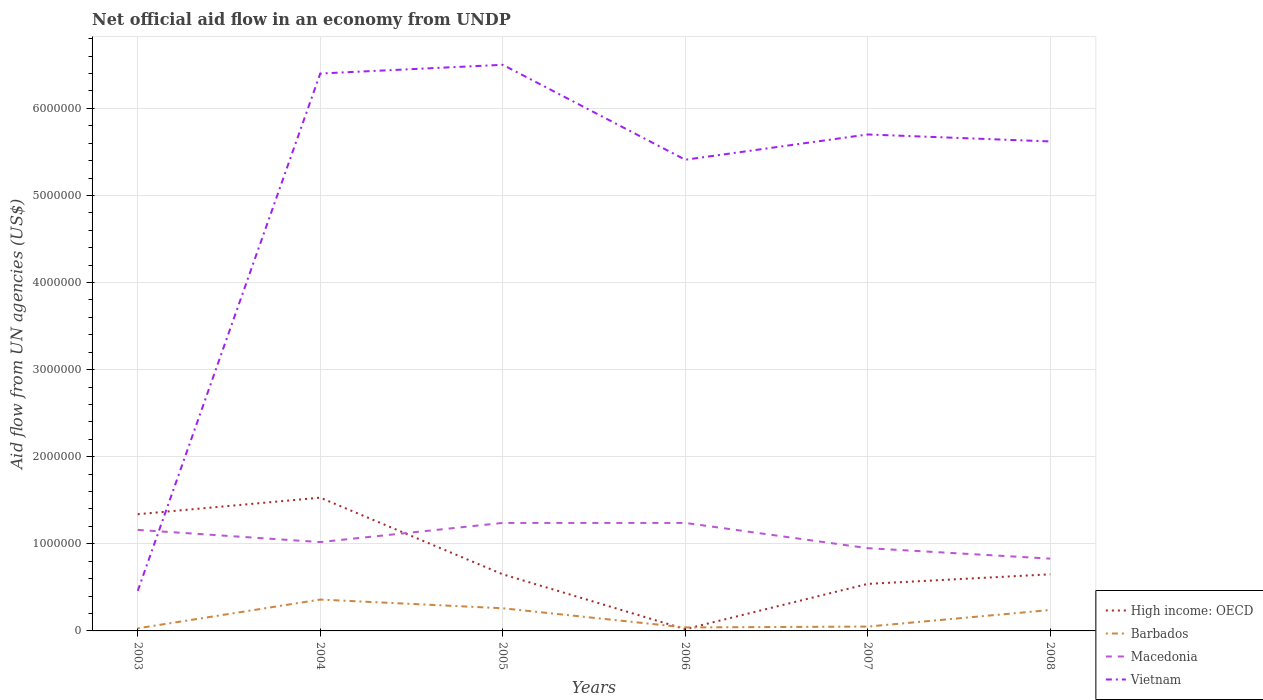How many different coloured lines are there?
Your answer should be very brief. 4. Is the number of lines equal to the number of legend labels?
Your answer should be compact. Yes. Across all years, what is the maximum net official aid flow in High income: OECD?
Offer a very short reply. 2.00e+04. What is the difference between the highest and the second highest net official aid flow in High income: OECD?
Provide a short and direct response. 1.51e+06. How many lines are there?
Offer a terse response. 4. How many years are there in the graph?
Offer a very short reply. 6. What is the difference between two consecutive major ticks on the Y-axis?
Ensure brevity in your answer.  1.00e+06. How many legend labels are there?
Offer a terse response. 4. What is the title of the graph?
Keep it short and to the point. Net official aid flow in an economy from UNDP. What is the label or title of the X-axis?
Your response must be concise. Years. What is the label or title of the Y-axis?
Offer a very short reply. Aid flow from UN agencies (US$). What is the Aid flow from UN agencies (US$) of High income: OECD in 2003?
Offer a terse response. 1.34e+06. What is the Aid flow from UN agencies (US$) in Barbados in 2003?
Your answer should be compact. 3.00e+04. What is the Aid flow from UN agencies (US$) in Macedonia in 2003?
Offer a very short reply. 1.16e+06. What is the Aid flow from UN agencies (US$) in High income: OECD in 2004?
Your response must be concise. 1.53e+06. What is the Aid flow from UN agencies (US$) in Barbados in 2004?
Provide a succinct answer. 3.60e+05. What is the Aid flow from UN agencies (US$) of Macedonia in 2004?
Offer a very short reply. 1.02e+06. What is the Aid flow from UN agencies (US$) of Vietnam in 2004?
Keep it short and to the point. 6.40e+06. What is the Aid flow from UN agencies (US$) of High income: OECD in 2005?
Your response must be concise. 6.50e+05. What is the Aid flow from UN agencies (US$) in Barbados in 2005?
Keep it short and to the point. 2.60e+05. What is the Aid flow from UN agencies (US$) in Macedonia in 2005?
Your response must be concise. 1.24e+06. What is the Aid flow from UN agencies (US$) in Vietnam in 2005?
Keep it short and to the point. 6.50e+06. What is the Aid flow from UN agencies (US$) in Macedonia in 2006?
Give a very brief answer. 1.24e+06. What is the Aid flow from UN agencies (US$) in Vietnam in 2006?
Your answer should be very brief. 5.41e+06. What is the Aid flow from UN agencies (US$) of High income: OECD in 2007?
Your answer should be very brief. 5.40e+05. What is the Aid flow from UN agencies (US$) in Barbados in 2007?
Ensure brevity in your answer.  5.00e+04. What is the Aid flow from UN agencies (US$) of Macedonia in 2007?
Give a very brief answer. 9.50e+05. What is the Aid flow from UN agencies (US$) of Vietnam in 2007?
Ensure brevity in your answer.  5.70e+06. What is the Aid flow from UN agencies (US$) of High income: OECD in 2008?
Give a very brief answer. 6.50e+05. What is the Aid flow from UN agencies (US$) of Macedonia in 2008?
Provide a short and direct response. 8.30e+05. What is the Aid flow from UN agencies (US$) in Vietnam in 2008?
Make the answer very short. 5.62e+06. Across all years, what is the maximum Aid flow from UN agencies (US$) of High income: OECD?
Keep it short and to the point. 1.53e+06. Across all years, what is the maximum Aid flow from UN agencies (US$) of Barbados?
Provide a succinct answer. 3.60e+05. Across all years, what is the maximum Aid flow from UN agencies (US$) of Macedonia?
Offer a terse response. 1.24e+06. Across all years, what is the maximum Aid flow from UN agencies (US$) in Vietnam?
Keep it short and to the point. 6.50e+06. Across all years, what is the minimum Aid flow from UN agencies (US$) of High income: OECD?
Provide a short and direct response. 2.00e+04. Across all years, what is the minimum Aid flow from UN agencies (US$) in Macedonia?
Make the answer very short. 8.30e+05. Across all years, what is the minimum Aid flow from UN agencies (US$) in Vietnam?
Provide a short and direct response. 4.60e+05. What is the total Aid flow from UN agencies (US$) of High income: OECD in the graph?
Your answer should be compact. 4.73e+06. What is the total Aid flow from UN agencies (US$) of Barbados in the graph?
Offer a terse response. 9.80e+05. What is the total Aid flow from UN agencies (US$) of Macedonia in the graph?
Provide a succinct answer. 6.44e+06. What is the total Aid flow from UN agencies (US$) of Vietnam in the graph?
Your response must be concise. 3.01e+07. What is the difference between the Aid flow from UN agencies (US$) in Barbados in 2003 and that in 2004?
Ensure brevity in your answer.  -3.30e+05. What is the difference between the Aid flow from UN agencies (US$) of Macedonia in 2003 and that in 2004?
Your answer should be very brief. 1.40e+05. What is the difference between the Aid flow from UN agencies (US$) in Vietnam in 2003 and that in 2004?
Offer a very short reply. -5.94e+06. What is the difference between the Aid flow from UN agencies (US$) of High income: OECD in 2003 and that in 2005?
Offer a terse response. 6.90e+05. What is the difference between the Aid flow from UN agencies (US$) in Vietnam in 2003 and that in 2005?
Ensure brevity in your answer.  -6.04e+06. What is the difference between the Aid flow from UN agencies (US$) of High income: OECD in 2003 and that in 2006?
Your answer should be very brief. 1.32e+06. What is the difference between the Aid flow from UN agencies (US$) of Barbados in 2003 and that in 2006?
Offer a terse response. -10000. What is the difference between the Aid flow from UN agencies (US$) of Macedonia in 2003 and that in 2006?
Give a very brief answer. -8.00e+04. What is the difference between the Aid flow from UN agencies (US$) of Vietnam in 2003 and that in 2006?
Provide a short and direct response. -4.95e+06. What is the difference between the Aid flow from UN agencies (US$) of Vietnam in 2003 and that in 2007?
Provide a short and direct response. -5.24e+06. What is the difference between the Aid flow from UN agencies (US$) in High income: OECD in 2003 and that in 2008?
Your answer should be very brief. 6.90e+05. What is the difference between the Aid flow from UN agencies (US$) of Barbados in 2003 and that in 2008?
Your response must be concise. -2.10e+05. What is the difference between the Aid flow from UN agencies (US$) in Macedonia in 2003 and that in 2008?
Keep it short and to the point. 3.30e+05. What is the difference between the Aid flow from UN agencies (US$) in Vietnam in 2003 and that in 2008?
Provide a short and direct response. -5.16e+06. What is the difference between the Aid flow from UN agencies (US$) of High income: OECD in 2004 and that in 2005?
Offer a very short reply. 8.80e+05. What is the difference between the Aid flow from UN agencies (US$) in Barbados in 2004 and that in 2005?
Ensure brevity in your answer.  1.00e+05. What is the difference between the Aid flow from UN agencies (US$) of Vietnam in 2004 and that in 2005?
Make the answer very short. -1.00e+05. What is the difference between the Aid flow from UN agencies (US$) in High income: OECD in 2004 and that in 2006?
Your answer should be compact. 1.51e+06. What is the difference between the Aid flow from UN agencies (US$) of Vietnam in 2004 and that in 2006?
Your answer should be very brief. 9.90e+05. What is the difference between the Aid flow from UN agencies (US$) in High income: OECD in 2004 and that in 2007?
Offer a very short reply. 9.90e+05. What is the difference between the Aid flow from UN agencies (US$) of Barbados in 2004 and that in 2007?
Ensure brevity in your answer.  3.10e+05. What is the difference between the Aid flow from UN agencies (US$) of Vietnam in 2004 and that in 2007?
Provide a succinct answer. 7.00e+05. What is the difference between the Aid flow from UN agencies (US$) in High income: OECD in 2004 and that in 2008?
Provide a short and direct response. 8.80e+05. What is the difference between the Aid flow from UN agencies (US$) of Vietnam in 2004 and that in 2008?
Your answer should be compact. 7.80e+05. What is the difference between the Aid flow from UN agencies (US$) in High income: OECD in 2005 and that in 2006?
Your response must be concise. 6.30e+05. What is the difference between the Aid flow from UN agencies (US$) of Barbados in 2005 and that in 2006?
Make the answer very short. 2.20e+05. What is the difference between the Aid flow from UN agencies (US$) in Macedonia in 2005 and that in 2006?
Give a very brief answer. 0. What is the difference between the Aid flow from UN agencies (US$) in Vietnam in 2005 and that in 2006?
Provide a succinct answer. 1.09e+06. What is the difference between the Aid flow from UN agencies (US$) in High income: OECD in 2005 and that in 2007?
Give a very brief answer. 1.10e+05. What is the difference between the Aid flow from UN agencies (US$) of Macedonia in 2005 and that in 2007?
Offer a very short reply. 2.90e+05. What is the difference between the Aid flow from UN agencies (US$) of Vietnam in 2005 and that in 2007?
Provide a short and direct response. 8.00e+05. What is the difference between the Aid flow from UN agencies (US$) in Vietnam in 2005 and that in 2008?
Provide a short and direct response. 8.80e+05. What is the difference between the Aid flow from UN agencies (US$) in High income: OECD in 2006 and that in 2007?
Your response must be concise. -5.20e+05. What is the difference between the Aid flow from UN agencies (US$) of Barbados in 2006 and that in 2007?
Provide a short and direct response. -10000. What is the difference between the Aid flow from UN agencies (US$) in Vietnam in 2006 and that in 2007?
Offer a terse response. -2.90e+05. What is the difference between the Aid flow from UN agencies (US$) of High income: OECD in 2006 and that in 2008?
Your answer should be very brief. -6.30e+05. What is the difference between the Aid flow from UN agencies (US$) in Vietnam in 2006 and that in 2008?
Ensure brevity in your answer.  -2.10e+05. What is the difference between the Aid flow from UN agencies (US$) in High income: OECD in 2007 and that in 2008?
Offer a terse response. -1.10e+05. What is the difference between the Aid flow from UN agencies (US$) in Barbados in 2007 and that in 2008?
Make the answer very short. -1.90e+05. What is the difference between the Aid flow from UN agencies (US$) in High income: OECD in 2003 and the Aid flow from UN agencies (US$) in Barbados in 2004?
Give a very brief answer. 9.80e+05. What is the difference between the Aid flow from UN agencies (US$) of High income: OECD in 2003 and the Aid flow from UN agencies (US$) of Vietnam in 2004?
Your answer should be very brief. -5.06e+06. What is the difference between the Aid flow from UN agencies (US$) in Barbados in 2003 and the Aid flow from UN agencies (US$) in Macedonia in 2004?
Offer a terse response. -9.90e+05. What is the difference between the Aid flow from UN agencies (US$) of Barbados in 2003 and the Aid flow from UN agencies (US$) of Vietnam in 2004?
Give a very brief answer. -6.37e+06. What is the difference between the Aid flow from UN agencies (US$) of Macedonia in 2003 and the Aid flow from UN agencies (US$) of Vietnam in 2004?
Provide a short and direct response. -5.24e+06. What is the difference between the Aid flow from UN agencies (US$) of High income: OECD in 2003 and the Aid flow from UN agencies (US$) of Barbados in 2005?
Your response must be concise. 1.08e+06. What is the difference between the Aid flow from UN agencies (US$) in High income: OECD in 2003 and the Aid flow from UN agencies (US$) in Macedonia in 2005?
Offer a terse response. 1.00e+05. What is the difference between the Aid flow from UN agencies (US$) of High income: OECD in 2003 and the Aid flow from UN agencies (US$) of Vietnam in 2005?
Make the answer very short. -5.16e+06. What is the difference between the Aid flow from UN agencies (US$) in Barbados in 2003 and the Aid flow from UN agencies (US$) in Macedonia in 2005?
Your answer should be very brief. -1.21e+06. What is the difference between the Aid flow from UN agencies (US$) of Barbados in 2003 and the Aid flow from UN agencies (US$) of Vietnam in 2005?
Make the answer very short. -6.47e+06. What is the difference between the Aid flow from UN agencies (US$) of Macedonia in 2003 and the Aid flow from UN agencies (US$) of Vietnam in 2005?
Your answer should be compact. -5.34e+06. What is the difference between the Aid flow from UN agencies (US$) of High income: OECD in 2003 and the Aid flow from UN agencies (US$) of Barbados in 2006?
Your answer should be compact. 1.30e+06. What is the difference between the Aid flow from UN agencies (US$) in High income: OECD in 2003 and the Aid flow from UN agencies (US$) in Macedonia in 2006?
Your response must be concise. 1.00e+05. What is the difference between the Aid flow from UN agencies (US$) of High income: OECD in 2003 and the Aid flow from UN agencies (US$) of Vietnam in 2006?
Keep it short and to the point. -4.07e+06. What is the difference between the Aid flow from UN agencies (US$) of Barbados in 2003 and the Aid flow from UN agencies (US$) of Macedonia in 2006?
Keep it short and to the point. -1.21e+06. What is the difference between the Aid flow from UN agencies (US$) in Barbados in 2003 and the Aid flow from UN agencies (US$) in Vietnam in 2006?
Provide a short and direct response. -5.38e+06. What is the difference between the Aid flow from UN agencies (US$) of Macedonia in 2003 and the Aid flow from UN agencies (US$) of Vietnam in 2006?
Give a very brief answer. -4.25e+06. What is the difference between the Aid flow from UN agencies (US$) of High income: OECD in 2003 and the Aid flow from UN agencies (US$) of Barbados in 2007?
Make the answer very short. 1.29e+06. What is the difference between the Aid flow from UN agencies (US$) of High income: OECD in 2003 and the Aid flow from UN agencies (US$) of Vietnam in 2007?
Give a very brief answer. -4.36e+06. What is the difference between the Aid flow from UN agencies (US$) of Barbados in 2003 and the Aid flow from UN agencies (US$) of Macedonia in 2007?
Keep it short and to the point. -9.20e+05. What is the difference between the Aid flow from UN agencies (US$) in Barbados in 2003 and the Aid flow from UN agencies (US$) in Vietnam in 2007?
Provide a short and direct response. -5.67e+06. What is the difference between the Aid flow from UN agencies (US$) of Macedonia in 2003 and the Aid flow from UN agencies (US$) of Vietnam in 2007?
Offer a very short reply. -4.54e+06. What is the difference between the Aid flow from UN agencies (US$) in High income: OECD in 2003 and the Aid flow from UN agencies (US$) in Barbados in 2008?
Your answer should be very brief. 1.10e+06. What is the difference between the Aid flow from UN agencies (US$) in High income: OECD in 2003 and the Aid flow from UN agencies (US$) in Macedonia in 2008?
Make the answer very short. 5.10e+05. What is the difference between the Aid flow from UN agencies (US$) in High income: OECD in 2003 and the Aid flow from UN agencies (US$) in Vietnam in 2008?
Ensure brevity in your answer.  -4.28e+06. What is the difference between the Aid flow from UN agencies (US$) of Barbados in 2003 and the Aid flow from UN agencies (US$) of Macedonia in 2008?
Make the answer very short. -8.00e+05. What is the difference between the Aid flow from UN agencies (US$) of Barbados in 2003 and the Aid flow from UN agencies (US$) of Vietnam in 2008?
Offer a very short reply. -5.59e+06. What is the difference between the Aid flow from UN agencies (US$) in Macedonia in 2003 and the Aid flow from UN agencies (US$) in Vietnam in 2008?
Offer a terse response. -4.46e+06. What is the difference between the Aid flow from UN agencies (US$) of High income: OECD in 2004 and the Aid flow from UN agencies (US$) of Barbados in 2005?
Your response must be concise. 1.27e+06. What is the difference between the Aid flow from UN agencies (US$) of High income: OECD in 2004 and the Aid flow from UN agencies (US$) of Vietnam in 2005?
Make the answer very short. -4.97e+06. What is the difference between the Aid flow from UN agencies (US$) of Barbados in 2004 and the Aid flow from UN agencies (US$) of Macedonia in 2005?
Your answer should be compact. -8.80e+05. What is the difference between the Aid flow from UN agencies (US$) of Barbados in 2004 and the Aid flow from UN agencies (US$) of Vietnam in 2005?
Your response must be concise. -6.14e+06. What is the difference between the Aid flow from UN agencies (US$) in Macedonia in 2004 and the Aid flow from UN agencies (US$) in Vietnam in 2005?
Make the answer very short. -5.48e+06. What is the difference between the Aid flow from UN agencies (US$) in High income: OECD in 2004 and the Aid flow from UN agencies (US$) in Barbados in 2006?
Ensure brevity in your answer.  1.49e+06. What is the difference between the Aid flow from UN agencies (US$) of High income: OECD in 2004 and the Aid flow from UN agencies (US$) of Vietnam in 2006?
Your response must be concise. -3.88e+06. What is the difference between the Aid flow from UN agencies (US$) in Barbados in 2004 and the Aid flow from UN agencies (US$) in Macedonia in 2006?
Give a very brief answer. -8.80e+05. What is the difference between the Aid flow from UN agencies (US$) in Barbados in 2004 and the Aid flow from UN agencies (US$) in Vietnam in 2006?
Offer a terse response. -5.05e+06. What is the difference between the Aid flow from UN agencies (US$) of Macedonia in 2004 and the Aid flow from UN agencies (US$) of Vietnam in 2006?
Provide a succinct answer. -4.39e+06. What is the difference between the Aid flow from UN agencies (US$) in High income: OECD in 2004 and the Aid flow from UN agencies (US$) in Barbados in 2007?
Provide a succinct answer. 1.48e+06. What is the difference between the Aid flow from UN agencies (US$) of High income: OECD in 2004 and the Aid flow from UN agencies (US$) of Macedonia in 2007?
Your response must be concise. 5.80e+05. What is the difference between the Aid flow from UN agencies (US$) in High income: OECD in 2004 and the Aid flow from UN agencies (US$) in Vietnam in 2007?
Provide a succinct answer. -4.17e+06. What is the difference between the Aid flow from UN agencies (US$) in Barbados in 2004 and the Aid flow from UN agencies (US$) in Macedonia in 2007?
Your answer should be compact. -5.90e+05. What is the difference between the Aid flow from UN agencies (US$) in Barbados in 2004 and the Aid flow from UN agencies (US$) in Vietnam in 2007?
Your answer should be compact. -5.34e+06. What is the difference between the Aid flow from UN agencies (US$) of Macedonia in 2004 and the Aid flow from UN agencies (US$) of Vietnam in 2007?
Give a very brief answer. -4.68e+06. What is the difference between the Aid flow from UN agencies (US$) of High income: OECD in 2004 and the Aid flow from UN agencies (US$) of Barbados in 2008?
Offer a terse response. 1.29e+06. What is the difference between the Aid flow from UN agencies (US$) in High income: OECD in 2004 and the Aid flow from UN agencies (US$) in Vietnam in 2008?
Provide a short and direct response. -4.09e+06. What is the difference between the Aid flow from UN agencies (US$) in Barbados in 2004 and the Aid flow from UN agencies (US$) in Macedonia in 2008?
Keep it short and to the point. -4.70e+05. What is the difference between the Aid flow from UN agencies (US$) of Barbados in 2004 and the Aid flow from UN agencies (US$) of Vietnam in 2008?
Ensure brevity in your answer.  -5.26e+06. What is the difference between the Aid flow from UN agencies (US$) in Macedonia in 2004 and the Aid flow from UN agencies (US$) in Vietnam in 2008?
Offer a very short reply. -4.60e+06. What is the difference between the Aid flow from UN agencies (US$) of High income: OECD in 2005 and the Aid flow from UN agencies (US$) of Macedonia in 2006?
Your answer should be very brief. -5.90e+05. What is the difference between the Aid flow from UN agencies (US$) of High income: OECD in 2005 and the Aid flow from UN agencies (US$) of Vietnam in 2006?
Your response must be concise. -4.76e+06. What is the difference between the Aid flow from UN agencies (US$) in Barbados in 2005 and the Aid flow from UN agencies (US$) in Macedonia in 2006?
Make the answer very short. -9.80e+05. What is the difference between the Aid flow from UN agencies (US$) of Barbados in 2005 and the Aid flow from UN agencies (US$) of Vietnam in 2006?
Make the answer very short. -5.15e+06. What is the difference between the Aid flow from UN agencies (US$) of Macedonia in 2005 and the Aid flow from UN agencies (US$) of Vietnam in 2006?
Offer a very short reply. -4.17e+06. What is the difference between the Aid flow from UN agencies (US$) of High income: OECD in 2005 and the Aid flow from UN agencies (US$) of Barbados in 2007?
Your answer should be very brief. 6.00e+05. What is the difference between the Aid flow from UN agencies (US$) in High income: OECD in 2005 and the Aid flow from UN agencies (US$) in Vietnam in 2007?
Your answer should be very brief. -5.05e+06. What is the difference between the Aid flow from UN agencies (US$) of Barbados in 2005 and the Aid flow from UN agencies (US$) of Macedonia in 2007?
Your response must be concise. -6.90e+05. What is the difference between the Aid flow from UN agencies (US$) in Barbados in 2005 and the Aid flow from UN agencies (US$) in Vietnam in 2007?
Your answer should be very brief. -5.44e+06. What is the difference between the Aid flow from UN agencies (US$) of Macedonia in 2005 and the Aid flow from UN agencies (US$) of Vietnam in 2007?
Make the answer very short. -4.46e+06. What is the difference between the Aid flow from UN agencies (US$) of High income: OECD in 2005 and the Aid flow from UN agencies (US$) of Macedonia in 2008?
Your answer should be compact. -1.80e+05. What is the difference between the Aid flow from UN agencies (US$) in High income: OECD in 2005 and the Aid flow from UN agencies (US$) in Vietnam in 2008?
Your answer should be compact. -4.97e+06. What is the difference between the Aid flow from UN agencies (US$) in Barbados in 2005 and the Aid flow from UN agencies (US$) in Macedonia in 2008?
Your answer should be very brief. -5.70e+05. What is the difference between the Aid flow from UN agencies (US$) of Barbados in 2005 and the Aid flow from UN agencies (US$) of Vietnam in 2008?
Ensure brevity in your answer.  -5.36e+06. What is the difference between the Aid flow from UN agencies (US$) of Macedonia in 2005 and the Aid flow from UN agencies (US$) of Vietnam in 2008?
Your answer should be very brief. -4.38e+06. What is the difference between the Aid flow from UN agencies (US$) of High income: OECD in 2006 and the Aid flow from UN agencies (US$) of Macedonia in 2007?
Offer a terse response. -9.30e+05. What is the difference between the Aid flow from UN agencies (US$) of High income: OECD in 2006 and the Aid flow from UN agencies (US$) of Vietnam in 2007?
Provide a succinct answer. -5.68e+06. What is the difference between the Aid flow from UN agencies (US$) of Barbados in 2006 and the Aid flow from UN agencies (US$) of Macedonia in 2007?
Offer a terse response. -9.10e+05. What is the difference between the Aid flow from UN agencies (US$) of Barbados in 2006 and the Aid flow from UN agencies (US$) of Vietnam in 2007?
Give a very brief answer. -5.66e+06. What is the difference between the Aid flow from UN agencies (US$) in Macedonia in 2006 and the Aid flow from UN agencies (US$) in Vietnam in 2007?
Provide a short and direct response. -4.46e+06. What is the difference between the Aid flow from UN agencies (US$) in High income: OECD in 2006 and the Aid flow from UN agencies (US$) in Barbados in 2008?
Offer a very short reply. -2.20e+05. What is the difference between the Aid flow from UN agencies (US$) in High income: OECD in 2006 and the Aid flow from UN agencies (US$) in Macedonia in 2008?
Make the answer very short. -8.10e+05. What is the difference between the Aid flow from UN agencies (US$) in High income: OECD in 2006 and the Aid flow from UN agencies (US$) in Vietnam in 2008?
Provide a succinct answer. -5.60e+06. What is the difference between the Aid flow from UN agencies (US$) of Barbados in 2006 and the Aid flow from UN agencies (US$) of Macedonia in 2008?
Your answer should be compact. -7.90e+05. What is the difference between the Aid flow from UN agencies (US$) in Barbados in 2006 and the Aid flow from UN agencies (US$) in Vietnam in 2008?
Your answer should be very brief. -5.58e+06. What is the difference between the Aid flow from UN agencies (US$) in Macedonia in 2006 and the Aid flow from UN agencies (US$) in Vietnam in 2008?
Keep it short and to the point. -4.38e+06. What is the difference between the Aid flow from UN agencies (US$) of High income: OECD in 2007 and the Aid flow from UN agencies (US$) of Barbados in 2008?
Provide a succinct answer. 3.00e+05. What is the difference between the Aid flow from UN agencies (US$) in High income: OECD in 2007 and the Aid flow from UN agencies (US$) in Macedonia in 2008?
Give a very brief answer. -2.90e+05. What is the difference between the Aid flow from UN agencies (US$) of High income: OECD in 2007 and the Aid flow from UN agencies (US$) of Vietnam in 2008?
Offer a very short reply. -5.08e+06. What is the difference between the Aid flow from UN agencies (US$) of Barbados in 2007 and the Aid flow from UN agencies (US$) of Macedonia in 2008?
Offer a terse response. -7.80e+05. What is the difference between the Aid flow from UN agencies (US$) in Barbados in 2007 and the Aid flow from UN agencies (US$) in Vietnam in 2008?
Ensure brevity in your answer.  -5.57e+06. What is the difference between the Aid flow from UN agencies (US$) in Macedonia in 2007 and the Aid flow from UN agencies (US$) in Vietnam in 2008?
Your response must be concise. -4.67e+06. What is the average Aid flow from UN agencies (US$) of High income: OECD per year?
Offer a very short reply. 7.88e+05. What is the average Aid flow from UN agencies (US$) of Barbados per year?
Your response must be concise. 1.63e+05. What is the average Aid flow from UN agencies (US$) of Macedonia per year?
Ensure brevity in your answer.  1.07e+06. What is the average Aid flow from UN agencies (US$) of Vietnam per year?
Your response must be concise. 5.02e+06. In the year 2003, what is the difference between the Aid flow from UN agencies (US$) of High income: OECD and Aid flow from UN agencies (US$) of Barbados?
Ensure brevity in your answer.  1.31e+06. In the year 2003, what is the difference between the Aid flow from UN agencies (US$) of High income: OECD and Aid flow from UN agencies (US$) of Macedonia?
Give a very brief answer. 1.80e+05. In the year 2003, what is the difference between the Aid flow from UN agencies (US$) of High income: OECD and Aid flow from UN agencies (US$) of Vietnam?
Ensure brevity in your answer.  8.80e+05. In the year 2003, what is the difference between the Aid flow from UN agencies (US$) of Barbados and Aid flow from UN agencies (US$) of Macedonia?
Your answer should be compact. -1.13e+06. In the year 2003, what is the difference between the Aid flow from UN agencies (US$) of Barbados and Aid flow from UN agencies (US$) of Vietnam?
Provide a short and direct response. -4.30e+05. In the year 2004, what is the difference between the Aid flow from UN agencies (US$) in High income: OECD and Aid flow from UN agencies (US$) in Barbados?
Ensure brevity in your answer.  1.17e+06. In the year 2004, what is the difference between the Aid flow from UN agencies (US$) in High income: OECD and Aid flow from UN agencies (US$) in Macedonia?
Provide a succinct answer. 5.10e+05. In the year 2004, what is the difference between the Aid flow from UN agencies (US$) of High income: OECD and Aid flow from UN agencies (US$) of Vietnam?
Keep it short and to the point. -4.87e+06. In the year 2004, what is the difference between the Aid flow from UN agencies (US$) of Barbados and Aid flow from UN agencies (US$) of Macedonia?
Offer a terse response. -6.60e+05. In the year 2004, what is the difference between the Aid flow from UN agencies (US$) of Barbados and Aid flow from UN agencies (US$) of Vietnam?
Make the answer very short. -6.04e+06. In the year 2004, what is the difference between the Aid flow from UN agencies (US$) in Macedonia and Aid flow from UN agencies (US$) in Vietnam?
Give a very brief answer. -5.38e+06. In the year 2005, what is the difference between the Aid flow from UN agencies (US$) in High income: OECD and Aid flow from UN agencies (US$) in Macedonia?
Make the answer very short. -5.90e+05. In the year 2005, what is the difference between the Aid flow from UN agencies (US$) in High income: OECD and Aid flow from UN agencies (US$) in Vietnam?
Make the answer very short. -5.85e+06. In the year 2005, what is the difference between the Aid flow from UN agencies (US$) in Barbados and Aid flow from UN agencies (US$) in Macedonia?
Offer a terse response. -9.80e+05. In the year 2005, what is the difference between the Aid flow from UN agencies (US$) in Barbados and Aid flow from UN agencies (US$) in Vietnam?
Your response must be concise. -6.24e+06. In the year 2005, what is the difference between the Aid flow from UN agencies (US$) in Macedonia and Aid flow from UN agencies (US$) in Vietnam?
Give a very brief answer. -5.26e+06. In the year 2006, what is the difference between the Aid flow from UN agencies (US$) of High income: OECD and Aid flow from UN agencies (US$) of Macedonia?
Provide a short and direct response. -1.22e+06. In the year 2006, what is the difference between the Aid flow from UN agencies (US$) in High income: OECD and Aid flow from UN agencies (US$) in Vietnam?
Your response must be concise. -5.39e+06. In the year 2006, what is the difference between the Aid flow from UN agencies (US$) of Barbados and Aid flow from UN agencies (US$) of Macedonia?
Provide a short and direct response. -1.20e+06. In the year 2006, what is the difference between the Aid flow from UN agencies (US$) of Barbados and Aid flow from UN agencies (US$) of Vietnam?
Your answer should be very brief. -5.37e+06. In the year 2006, what is the difference between the Aid flow from UN agencies (US$) of Macedonia and Aid flow from UN agencies (US$) of Vietnam?
Provide a succinct answer. -4.17e+06. In the year 2007, what is the difference between the Aid flow from UN agencies (US$) of High income: OECD and Aid flow from UN agencies (US$) of Barbados?
Offer a very short reply. 4.90e+05. In the year 2007, what is the difference between the Aid flow from UN agencies (US$) of High income: OECD and Aid flow from UN agencies (US$) of Macedonia?
Provide a short and direct response. -4.10e+05. In the year 2007, what is the difference between the Aid flow from UN agencies (US$) in High income: OECD and Aid flow from UN agencies (US$) in Vietnam?
Offer a terse response. -5.16e+06. In the year 2007, what is the difference between the Aid flow from UN agencies (US$) of Barbados and Aid flow from UN agencies (US$) of Macedonia?
Give a very brief answer. -9.00e+05. In the year 2007, what is the difference between the Aid flow from UN agencies (US$) of Barbados and Aid flow from UN agencies (US$) of Vietnam?
Offer a very short reply. -5.65e+06. In the year 2007, what is the difference between the Aid flow from UN agencies (US$) in Macedonia and Aid flow from UN agencies (US$) in Vietnam?
Your answer should be compact. -4.75e+06. In the year 2008, what is the difference between the Aid flow from UN agencies (US$) in High income: OECD and Aid flow from UN agencies (US$) in Vietnam?
Give a very brief answer. -4.97e+06. In the year 2008, what is the difference between the Aid flow from UN agencies (US$) in Barbados and Aid flow from UN agencies (US$) in Macedonia?
Your response must be concise. -5.90e+05. In the year 2008, what is the difference between the Aid flow from UN agencies (US$) in Barbados and Aid flow from UN agencies (US$) in Vietnam?
Ensure brevity in your answer.  -5.38e+06. In the year 2008, what is the difference between the Aid flow from UN agencies (US$) in Macedonia and Aid flow from UN agencies (US$) in Vietnam?
Your answer should be compact. -4.79e+06. What is the ratio of the Aid flow from UN agencies (US$) in High income: OECD in 2003 to that in 2004?
Your answer should be very brief. 0.88. What is the ratio of the Aid flow from UN agencies (US$) in Barbados in 2003 to that in 2004?
Make the answer very short. 0.08. What is the ratio of the Aid flow from UN agencies (US$) of Macedonia in 2003 to that in 2004?
Your response must be concise. 1.14. What is the ratio of the Aid flow from UN agencies (US$) of Vietnam in 2003 to that in 2004?
Your response must be concise. 0.07. What is the ratio of the Aid flow from UN agencies (US$) in High income: OECD in 2003 to that in 2005?
Give a very brief answer. 2.06. What is the ratio of the Aid flow from UN agencies (US$) in Barbados in 2003 to that in 2005?
Keep it short and to the point. 0.12. What is the ratio of the Aid flow from UN agencies (US$) in Macedonia in 2003 to that in 2005?
Provide a succinct answer. 0.94. What is the ratio of the Aid flow from UN agencies (US$) in Vietnam in 2003 to that in 2005?
Keep it short and to the point. 0.07. What is the ratio of the Aid flow from UN agencies (US$) in High income: OECD in 2003 to that in 2006?
Provide a short and direct response. 67. What is the ratio of the Aid flow from UN agencies (US$) of Barbados in 2003 to that in 2006?
Your answer should be very brief. 0.75. What is the ratio of the Aid flow from UN agencies (US$) of Macedonia in 2003 to that in 2006?
Offer a very short reply. 0.94. What is the ratio of the Aid flow from UN agencies (US$) of Vietnam in 2003 to that in 2006?
Give a very brief answer. 0.09. What is the ratio of the Aid flow from UN agencies (US$) of High income: OECD in 2003 to that in 2007?
Provide a short and direct response. 2.48. What is the ratio of the Aid flow from UN agencies (US$) of Barbados in 2003 to that in 2007?
Your response must be concise. 0.6. What is the ratio of the Aid flow from UN agencies (US$) of Macedonia in 2003 to that in 2007?
Keep it short and to the point. 1.22. What is the ratio of the Aid flow from UN agencies (US$) of Vietnam in 2003 to that in 2007?
Keep it short and to the point. 0.08. What is the ratio of the Aid flow from UN agencies (US$) in High income: OECD in 2003 to that in 2008?
Provide a succinct answer. 2.06. What is the ratio of the Aid flow from UN agencies (US$) in Barbados in 2003 to that in 2008?
Keep it short and to the point. 0.12. What is the ratio of the Aid flow from UN agencies (US$) of Macedonia in 2003 to that in 2008?
Keep it short and to the point. 1.4. What is the ratio of the Aid flow from UN agencies (US$) in Vietnam in 2003 to that in 2008?
Give a very brief answer. 0.08. What is the ratio of the Aid flow from UN agencies (US$) of High income: OECD in 2004 to that in 2005?
Your answer should be compact. 2.35. What is the ratio of the Aid flow from UN agencies (US$) of Barbados in 2004 to that in 2005?
Offer a terse response. 1.38. What is the ratio of the Aid flow from UN agencies (US$) in Macedonia in 2004 to that in 2005?
Your answer should be compact. 0.82. What is the ratio of the Aid flow from UN agencies (US$) of Vietnam in 2004 to that in 2005?
Provide a succinct answer. 0.98. What is the ratio of the Aid flow from UN agencies (US$) of High income: OECD in 2004 to that in 2006?
Your response must be concise. 76.5. What is the ratio of the Aid flow from UN agencies (US$) of Macedonia in 2004 to that in 2006?
Offer a very short reply. 0.82. What is the ratio of the Aid flow from UN agencies (US$) in Vietnam in 2004 to that in 2006?
Your response must be concise. 1.18. What is the ratio of the Aid flow from UN agencies (US$) in High income: OECD in 2004 to that in 2007?
Your answer should be compact. 2.83. What is the ratio of the Aid flow from UN agencies (US$) of Macedonia in 2004 to that in 2007?
Offer a terse response. 1.07. What is the ratio of the Aid flow from UN agencies (US$) of Vietnam in 2004 to that in 2007?
Offer a terse response. 1.12. What is the ratio of the Aid flow from UN agencies (US$) in High income: OECD in 2004 to that in 2008?
Give a very brief answer. 2.35. What is the ratio of the Aid flow from UN agencies (US$) in Barbados in 2004 to that in 2008?
Keep it short and to the point. 1.5. What is the ratio of the Aid flow from UN agencies (US$) in Macedonia in 2004 to that in 2008?
Offer a very short reply. 1.23. What is the ratio of the Aid flow from UN agencies (US$) of Vietnam in 2004 to that in 2008?
Offer a terse response. 1.14. What is the ratio of the Aid flow from UN agencies (US$) of High income: OECD in 2005 to that in 2006?
Keep it short and to the point. 32.5. What is the ratio of the Aid flow from UN agencies (US$) in Vietnam in 2005 to that in 2006?
Your answer should be very brief. 1.2. What is the ratio of the Aid flow from UN agencies (US$) in High income: OECD in 2005 to that in 2007?
Provide a succinct answer. 1.2. What is the ratio of the Aid flow from UN agencies (US$) of Macedonia in 2005 to that in 2007?
Make the answer very short. 1.31. What is the ratio of the Aid flow from UN agencies (US$) of Vietnam in 2005 to that in 2007?
Give a very brief answer. 1.14. What is the ratio of the Aid flow from UN agencies (US$) in High income: OECD in 2005 to that in 2008?
Provide a short and direct response. 1. What is the ratio of the Aid flow from UN agencies (US$) of Barbados in 2005 to that in 2008?
Your answer should be compact. 1.08. What is the ratio of the Aid flow from UN agencies (US$) of Macedonia in 2005 to that in 2008?
Your answer should be compact. 1.49. What is the ratio of the Aid flow from UN agencies (US$) in Vietnam in 2005 to that in 2008?
Provide a short and direct response. 1.16. What is the ratio of the Aid flow from UN agencies (US$) of High income: OECD in 2006 to that in 2007?
Keep it short and to the point. 0.04. What is the ratio of the Aid flow from UN agencies (US$) in Macedonia in 2006 to that in 2007?
Your answer should be compact. 1.31. What is the ratio of the Aid flow from UN agencies (US$) in Vietnam in 2006 to that in 2007?
Keep it short and to the point. 0.95. What is the ratio of the Aid flow from UN agencies (US$) in High income: OECD in 2006 to that in 2008?
Provide a succinct answer. 0.03. What is the ratio of the Aid flow from UN agencies (US$) of Macedonia in 2006 to that in 2008?
Provide a succinct answer. 1.49. What is the ratio of the Aid flow from UN agencies (US$) in Vietnam in 2006 to that in 2008?
Give a very brief answer. 0.96. What is the ratio of the Aid flow from UN agencies (US$) of High income: OECD in 2007 to that in 2008?
Provide a short and direct response. 0.83. What is the ratio of the Aid flow from UN agencies (US$) in Barbados in 2007 to that in 2008?
Your answer should be compact. 0.21. What is the ratio of the Aid flow from UN agencies (US$) of Macedonia in 2007 to that in 2008?
Your answer should be very brief. 1.14. What is the ratio of the Aid flow from UN agencies (US$) in Vietnam in 2007 to that in 2008?
Make the answer very short. 1.01. What is the difference between the highest and the second highest Aid flow from UN agencies (US$) of Barbados?
Give a very brief answer. 1.00e+05. What is the difference between the highest and the lowest Aid flow from UN agencies (US$) in High income: OECD?
Provide a short and direct response. 1.51e+06. What is the difference between the highest and the lowest Aid flow from UN agencies (US$) of Barbados?
Provide a short and direct response. 3.30e+05. What is the difference between the highest and the lowest Aid flow from UN agencies (US$) of Macedonia?
Your response must be concise. 4.10e+05. What is the difference between the highest and the lowest Aid flow from UN agencies (US$) of Vietnam?
Keep it short and to the point. 6.04e+06. 